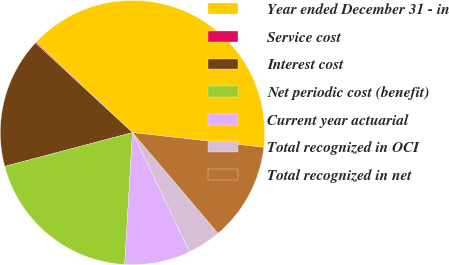Convert chart. <chart><loc_0><loc_0><loc_500><loc_500><pie_chart><fcel>Year ended December 31 - in<fcel>Service cost<fcel>Interest cost<fcel>Net periodic cost (benefit)<fcel>Current year actuarial<fcel>Total recognized in OCI<fcel>Total recognized in net<nl><fcel>39.79%<fcel>0.12%<fcel>15.99%<fcel>19.95%<fcel>8.05%<fcel>4.09%<fcel>12.02%<nl></chart> 